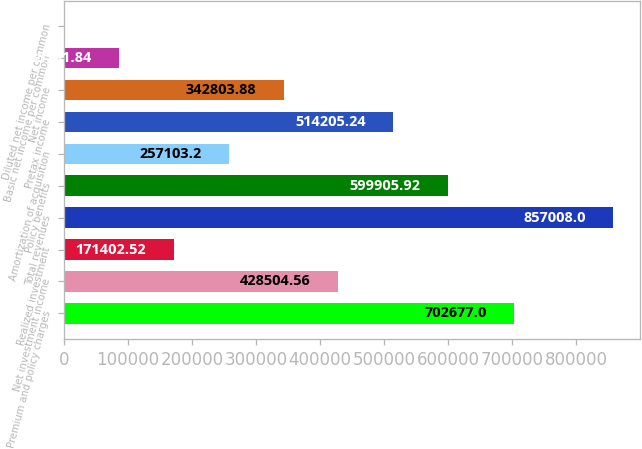Convert chart to OTSL. <chart><loc_0><loc_0><loc_500><loc_500><bar_chart><fcel>Premium and policy charges<fcel>Net investment income<fcel>Realized investment<fcel>Total revenues<fcel>Policy benefits<fcel>Amortization of acquisition<fcel>Pretax income<fcel>Net income<fcel>Basic net income per common<fcel>Diluted net income per common<nl><fcel>702677<fcel>428505<fcel>171403<fcel>857008<fcel>599906<fcel>257103<fcel>514205<fcel>342804<fcel>85701.8<fcel>1.16<nl></chart> 